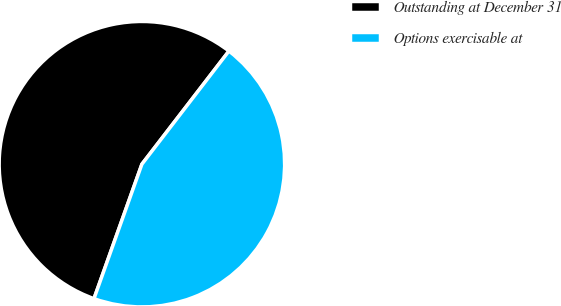Convert chart. <chart><loc_0><loc_0><loc_500><loc_500><pie_chart><fcel>Outstanding at December 31<fcel>Options exercisable at<nl><fcel>54.99%<fcel>45.01%<nl></chart> 